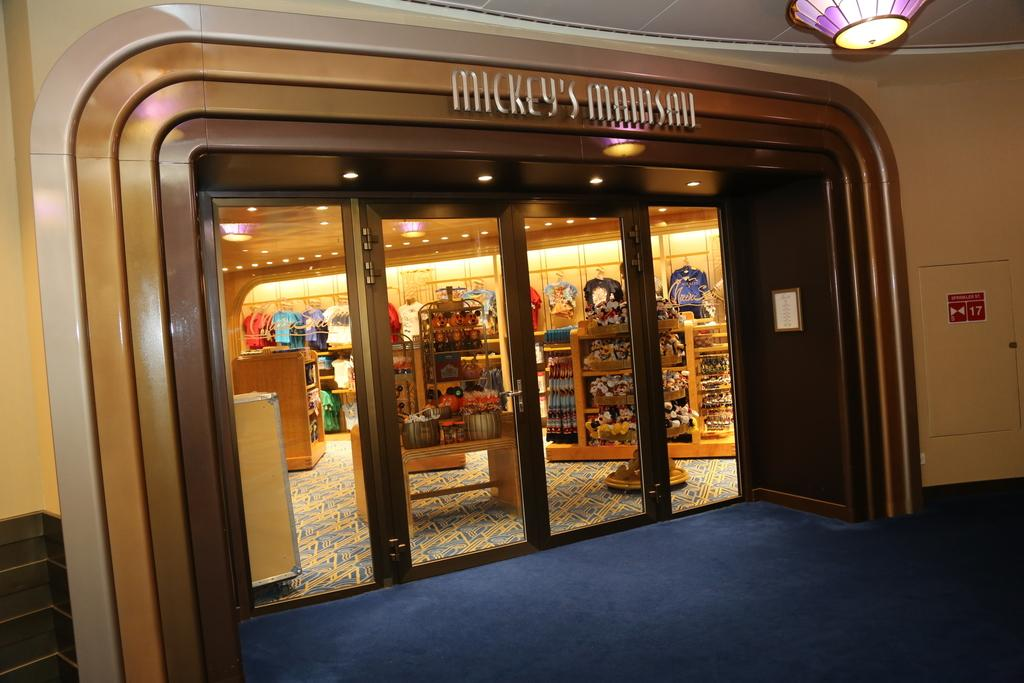<image>
Summarize the visual content of the image. a store front with words Mickey's Mainsail is lit up 